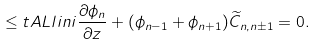Convert formula to latex. <formula><loc_0><loc_0><loc_500><loc_500>\leq t { A L l i n } i \frac { \partial \phi _ { n } } { \partial z } + ( \phi _ { n - 1 } + \phi _ { n + 1 } ) \widetilde { C } _ { n , n \pm 1 } = 0 .</formula> 